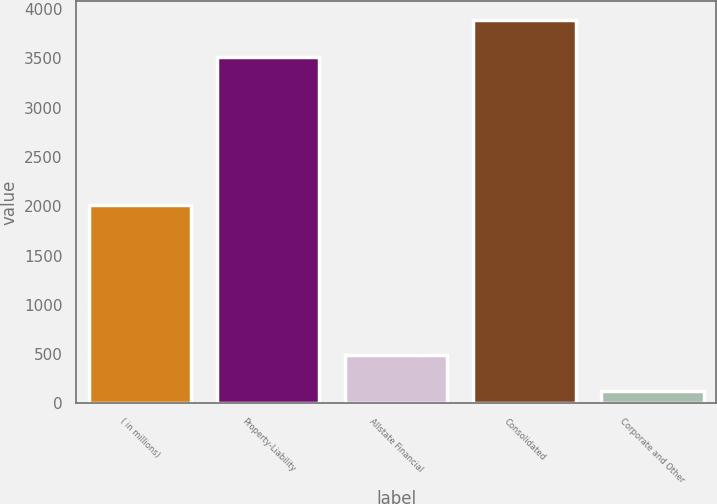<chart> <loc_0><loc_0><loc_500><loc_500><bar_chart><fcel>( in millions)<fcel>Property-Liability<fcel>Allstate Financial<fcel>Consolidated<fcel>Corporate and Other<nl><fcel>2010<fcel>3517<fcel>492.3<fcel>3885.3<fcel>124<nl></chart> 